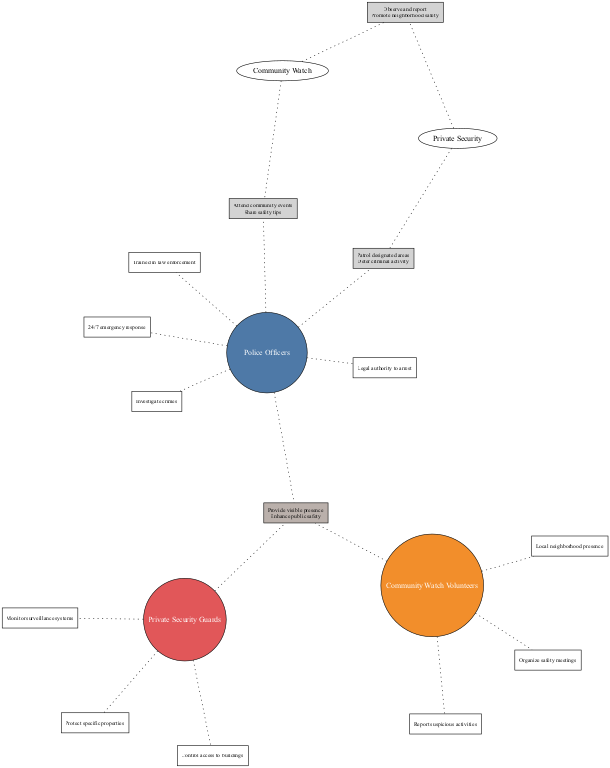What are the three groups compared in the Venn diagram? The diagram compares three groups: Police Officers, Community Watch Volunteers, and Private Security Guards. These groups are clearly labeled in each section of the Venn diagram, allowing easy identification.
Answer: Police Officers, Community Watch Volunteers, Private Security Guards How many roles are listed for Police Officers? The roles for Police Officers are four: 24/7 emergency response, legal authority to arrest, trained in law enforcement, and investigate crimes. By counting the number of phrases associated with the Police Officers, we find that there are four distinct roles.
Answer: 4 What shared activity do Police Officers and Community Watch Volunteers engage in? Both groups participate in community events and share safety tips. This shared activity is indicated within the overlapping section of the Venn diagram between Police Officers and Community Watch Volunteers, encompassing both shared roles.
Answer: Attend community events, share safety tips Which entity is responsible for monitoring surveillance systems? The responsibility of monitoring surveillance systems is listed under the Private Security Guards section. By scrutinizing this group’s specific roles, we can see that monitoring systems is explicitly stated as one of their tasks.
Answer: Private Security Guards What is one common role that all three groups share? A common role among Police Officers, Community Watch Volunteers, and Private Security Guards is to provide a visible presence. This role is detailed in the area where all three groups overlap, emphasizing their collective focus on visibility for safety.
Answer: Provide visible presence 